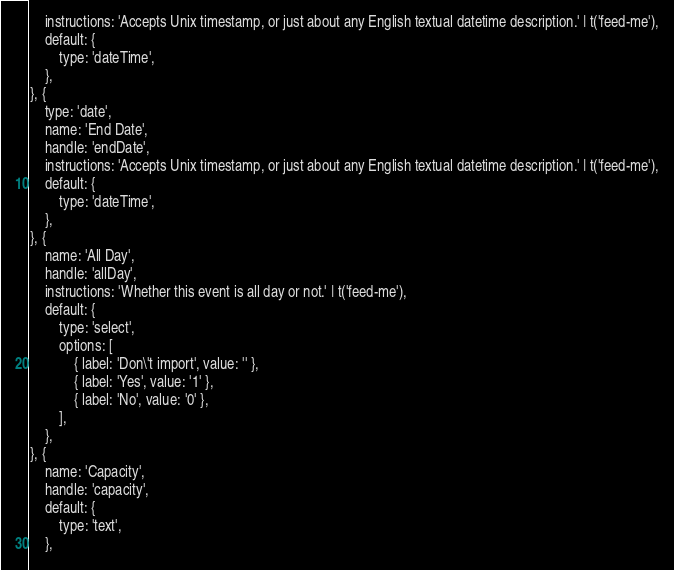Convert code to text. <code><loc_0><loc_0><loc_500><loc_500><_HTML_>    instructions: 'Accepts Unix timestamp, or just about any English textual datetime description.' | t('feed-me'),
    default: {
        type: 'dateTime',
    },
}, {
    type: 'date',
    name: 'End Date',
    handle: 'endDate',
    instructions: 'Accepts Unix timestamp, or just about any English textual datetime description.' | t('feed-me'),
    default: {
        type: 'dateTime',
    },
}, {
    name: 'All Day',
    handle: 'allDay',
    instructions: 'Whether this event is all day or not.' | t('feed-me'),
    default: {
        type: 'select',
        options: [
            { label: 'Don\'t import', value: '' },
            { label: 'Yes', value: '1' },
            { label: 'No', value: '0' },
        ],
    },
}, {
    name: 'Capacity',
    handle: 'capacity',
    default: {
        type: 'text',
    },</code> 